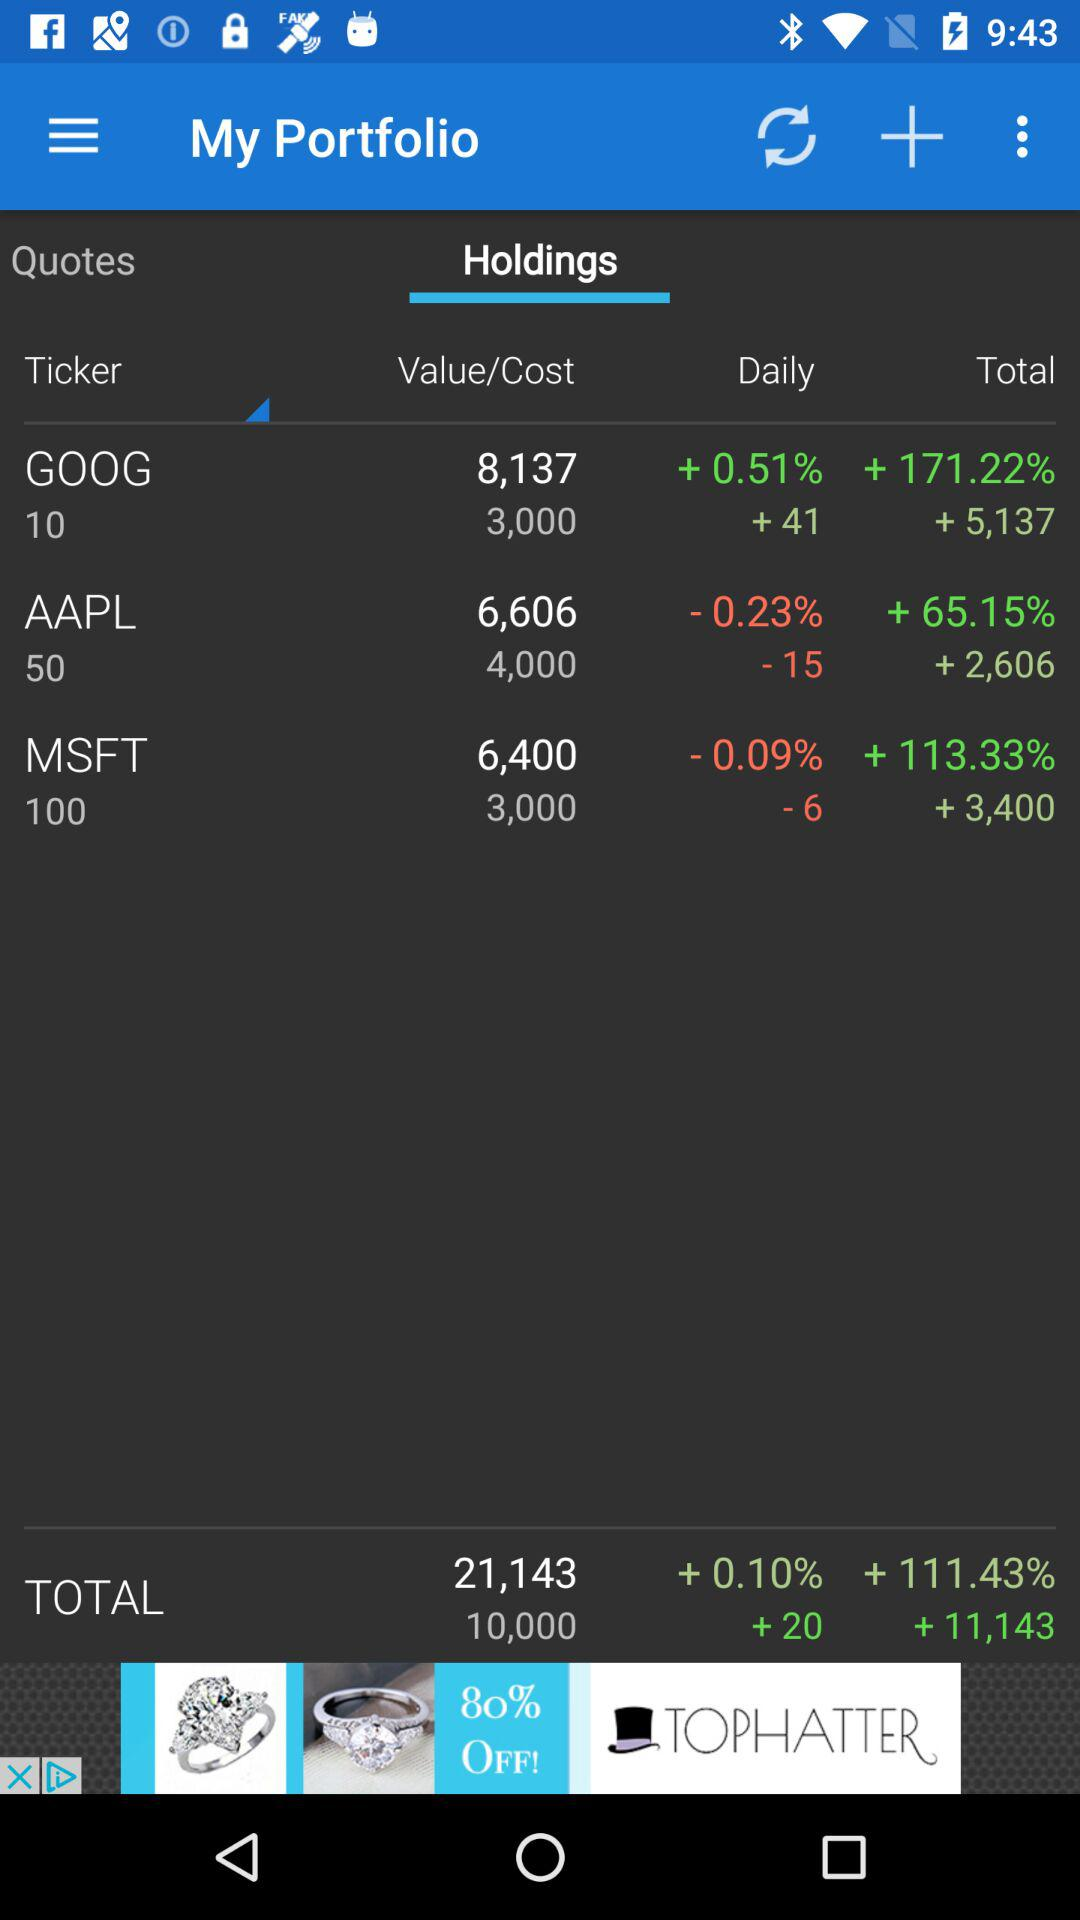What is the percentage value increase in AAPL? The percentage value increase in AAPL is 65.15. 